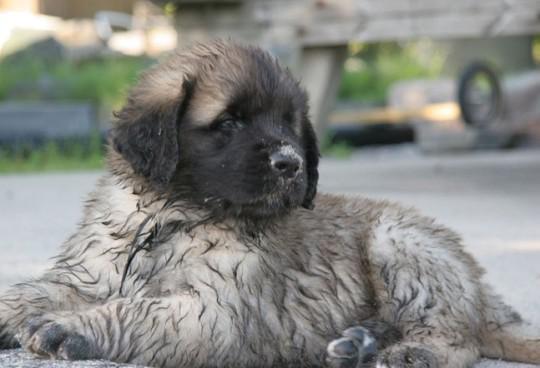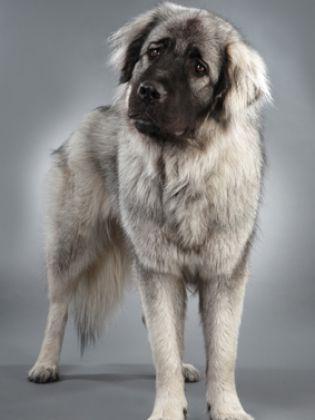The first image is the image on the left, the second image is the image on the right. Given the left and right images, does the statement "The right image has exactly two dogs." hold true? Answer yes or no. No. The first image is the image on the left, the second image is the image on the right. For the images displayed, is the sentence "In one of the images, one dog is predominantly white, while the other is predominantly brown." factually correct? Answer yes or no. No. 